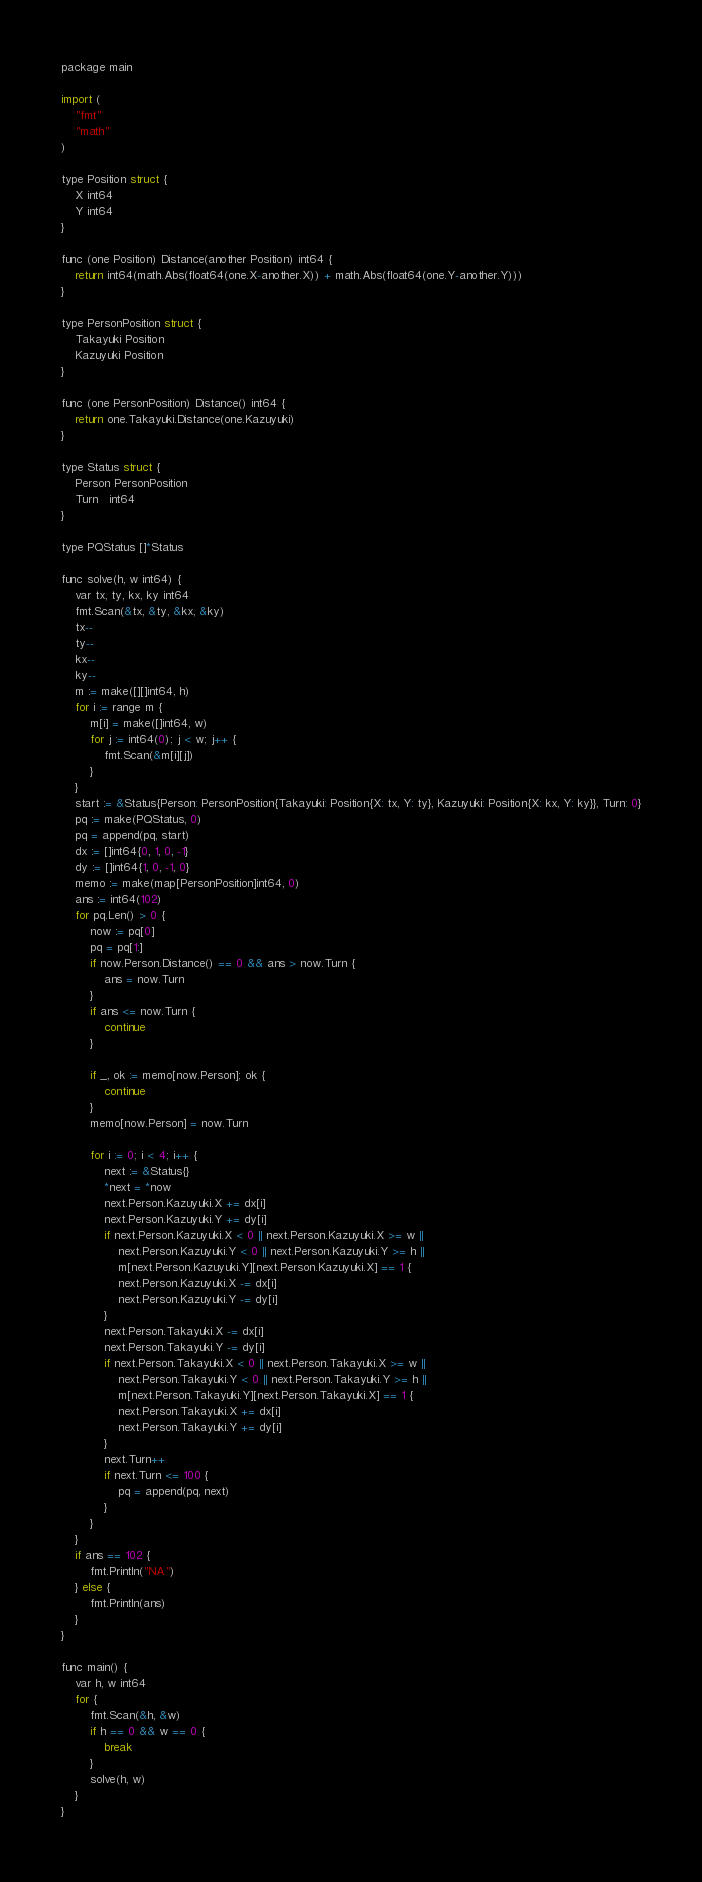Convert code to text. <code><loc_0><loc_0><loc_500><loc_500><_C++_>package main

import (
	"fmt"
	"math"
)

type Position struct {
	X int64
	Y int64
}

func (one Position) Distance(another Position) int64 {
	return int64(math.Abs(float64(one.X-another.X)) + math.Abs(float64(one.Y-another.Y)))
}

type PersonPosition struct {
	Takayuki Position
	Kazuyuki Position
}

func (one PersonPosition) Distance() int64 {
	return one.Takayuki.Distance(one.Kazuyuki)
}

type Status struct {
	Person PersonPosition
	Turn   int64
}

type PQStatus []*Status

func solve(h, w int64) {
	var tx, ty, kx, ky int64
	fmt.Scan(&tx, &ty, &kx, &ky)
	tx--
	ty--
	kx--
	ky--
	m := make([][]int64, h)
	for i := range m {
		m[i] = make([]int64, w)
		for j := int64(0); j < w; j++ {
			fmt.Scan(&m[i][j])
		}
	}
	start := &Status{Person: PersonPosition{Takayuki: Position{X: tx, Y: ty}, Kazuyuki: Position{X: kx, Y: ky}}, Turn: 0}
	pq := make(PQStatus, 0)
	pq = append(pq, start)
	dx := []int64{0, 1, 0, -1}
	dy := []int64{1, 0, -1, 0}
	memo := make(map[PersonPosition]int64, 0)
	ans := int64(102)
	for pq.Len() > 0 {
		now := pq[0]
		pq = pq[1:]
		if now.Person.Distance() == 0 && ans > now.Turn {
			ans = now.Turn
		}
		if ans <= now.Turn {
			continue
		}

		if _, ok := memo[now.Person]; ok {
			continue
		}
		memo[now.Person] = now.Turn

		for i := 0; i < 4; i++ {
			next := &Status{}
			*next = *now
			next.Person.Kazuyuki.X += dx[i]
			next.Person.Kazuyuki.Y += dy[i]
			if next.Person.Kazuyuki.X < 0 || next.Person.Kazuyuki.X >= w ||
				next.Person.Kazuyuki.Y < 0 || next.Person.Kazuyuki.Y >= h ||
				m[next.Person.Kazuyuki.Y][next.Person.Kazuyuki.X] == 1 {
				next.Person.Kazuyuki.X -= dx[i]
				next.Person.Kazuyuki.Y -= dy[i]
			}
			next.Person.Takayuki.X -= dx[i]
			next.Person.Takayuki.Y -= dy[i]
			if next.Person.Takayuki.X < 0 || next.Person.Takayuki.X >= w ||
				next.Person.Takayuki.Y < 0 || next.Person.Takayuki.Y >= h ||
				m[next.Person.Takayuki.Y][next.Person.Takayuki.X] == 1 {
				next.Person.Takayuki.X += dx[i]
				next.Person.Takayuki.Y += dy[i]
			}
			next.Turn++
			if next.Turn <= 100 {
				pq = append(pq, next)
			}
		}
	}
	if ans == 102 {
		fmt.Println("NA")
	} else {
		fmt.Println(ans)
	}
}

func main() {
	var h, w int64
	for {
		fmt.Scan(&h, &w)
		if h == 0 && w == 0 {
			break
		}
		solve(h, w)
	}
}

</code> 